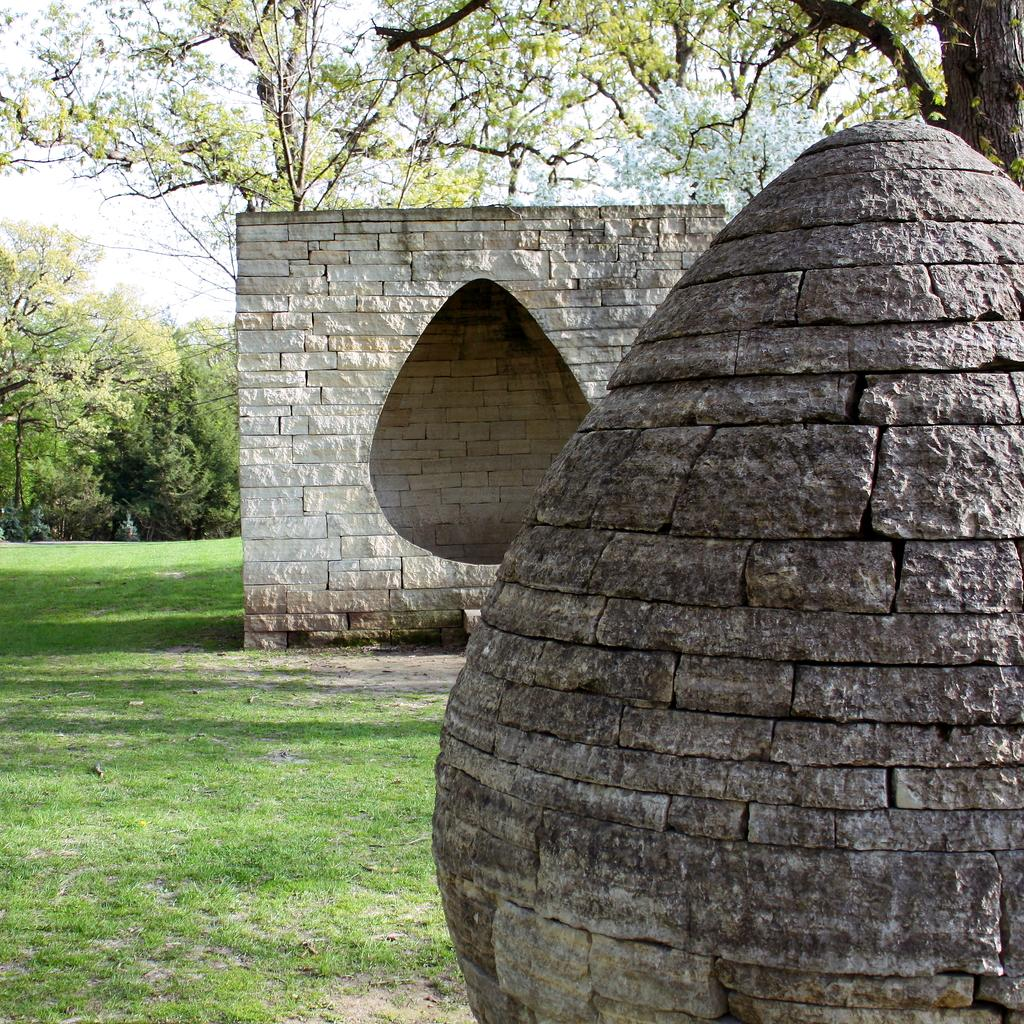What is the main subject of the image? The main subject of the image is a rock. Can you describe the shape of the rock? The rock is in an oval shape. What can be seen in the background of the image? There is a wall and trees in the background of the image. What type of terrain is visible on the left side of the image? There is a grassland on the left side of the image. What type of baseball equipment can be seen in the image? There is no baseball equipment present in the image; it features a rock, a wall, trees, and a grassland. What type of building is visible in the image? There is no building visible in the image; it features a rock, a wall, trees, and a grassland. 